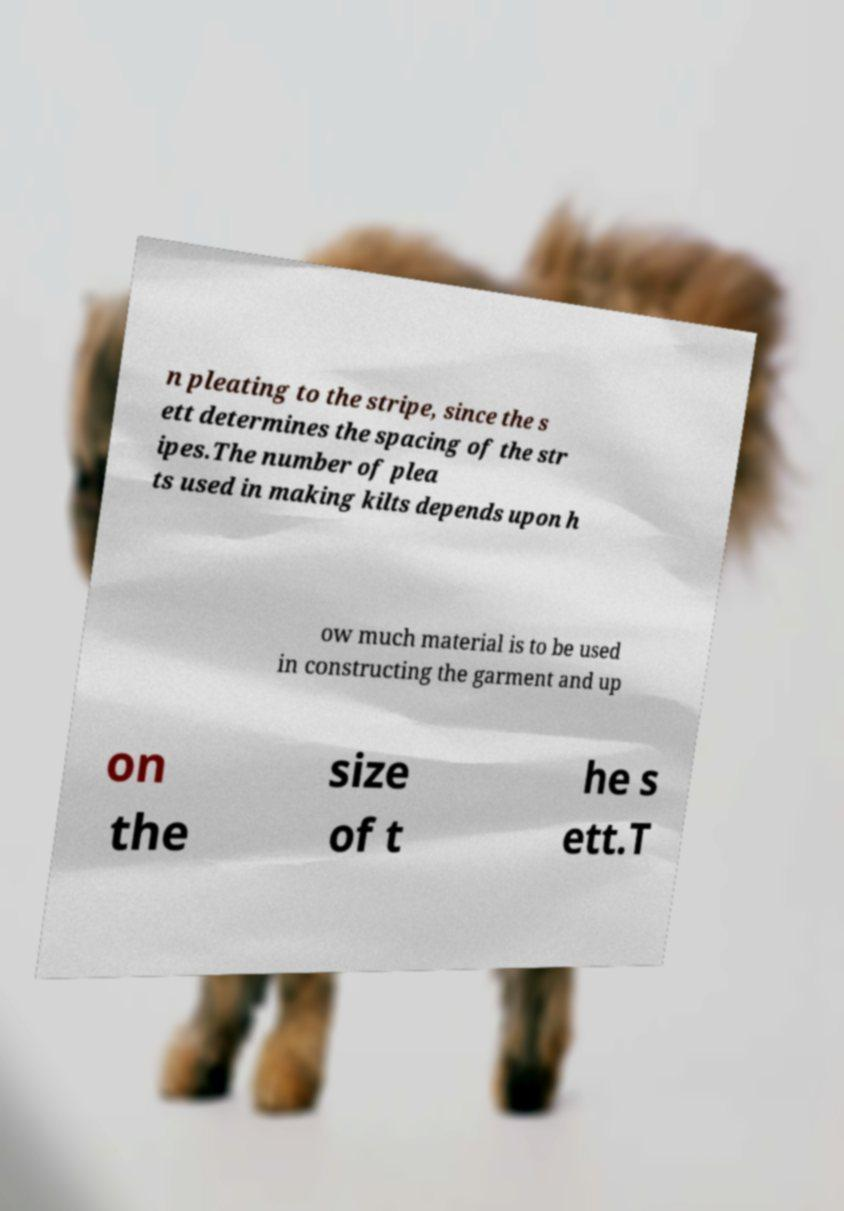Can you read and provide the text displayed in the image?This photo seems to have some interesting text. Can you extract and type it out for me? n pleating to the stripe, since the s ett determines the spacing of the str ipes.The number of plea ts used in making kilts depends upon h ow much material is to be used in constructing the garment and up on the size of t he s ett.T 